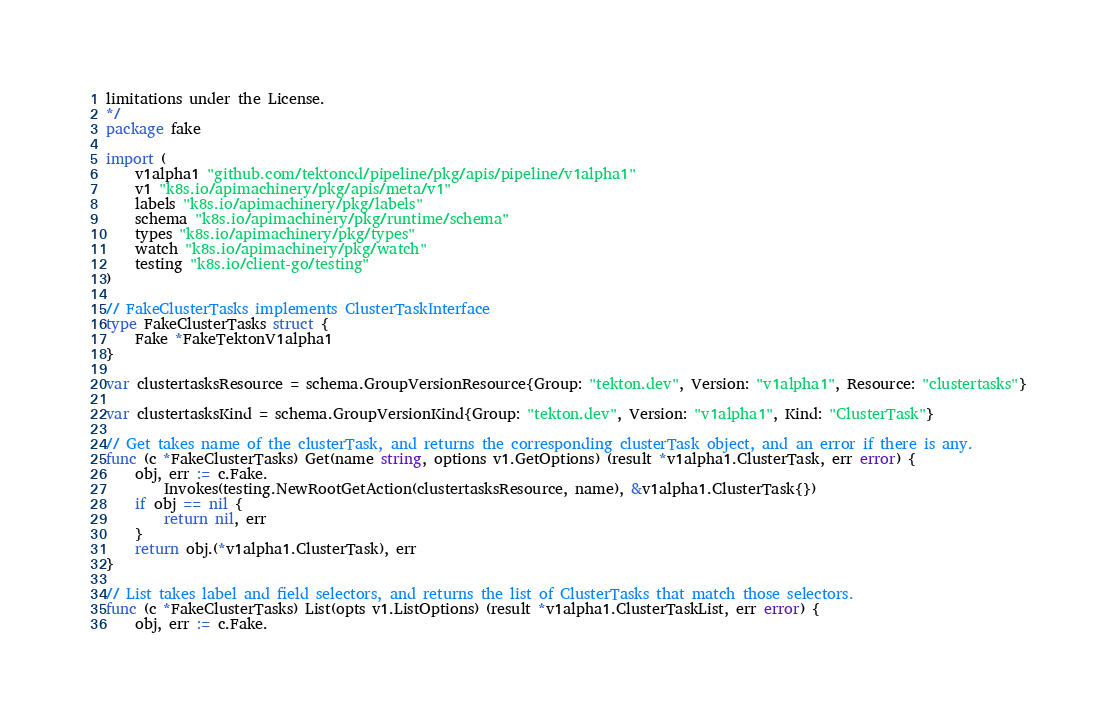Convert code to text. <code><loc_0><loc_0><loc_500><loc_500><_Go_>limitations under the License.
*/
package fake

import (
	v1alpha1 "github.com/tektoncd/pipeline/pkg/apis/pipeline/v1alpha1"
	v1 "k8s.io/apimachinery/pkg/apis/meta/v1"
	labels "k8s.io/apimachinery/pkg/labels"
	schema "k8s.io/apimachinery/pkg/runtime/schema"
	types "k8s.io/apimachinery/pkg/types"
	watch "k8s.io/apimachinery/pkg/watch"
	testing "k8s.io/client-go/testing"
)

// FakeClusterTasks implements ClusterTaskInterface
type FakeClusterTasks struct {
	Fake *FakeTektonV1alpha1
}

var clustertasksResource = schema.GroupVersionResource{Group: "tekton.dev", Version: "v1alpha1", Resource: "clustertasks"}

var clustertasksKind = schema.GroupVersionKind{Group: "tekton.dev", Version: "v1alpha1", Kind: "ClusterTask"}

// Get takes name of the clusterTask, and returns the corresponding clusterTask object, and an error if there is any.
func (c *FakeClusterTasks) Get(name string, options v1.GetOptions) (result *v1alpha1.ClusterTask, err error) {
	obj, err := c.Fake.
		Invokes(testing.NewRootGetAction(clustertasksResource, name), &v1alpha1.ClusterTask{})
	if obj == nil {
		return nil, err
	}
	return obj.(*v1alpha1.ClusterTask), err
}

// List takes label and field selectors, and returns the list of ClusterTasks that match those selectors.
func (c *FakeClusterTasks) List(opts v1.ListOptions) (result *v1alpha1.ClusterTaskList, err error) {
	obj, err := c.Fake.</code> 